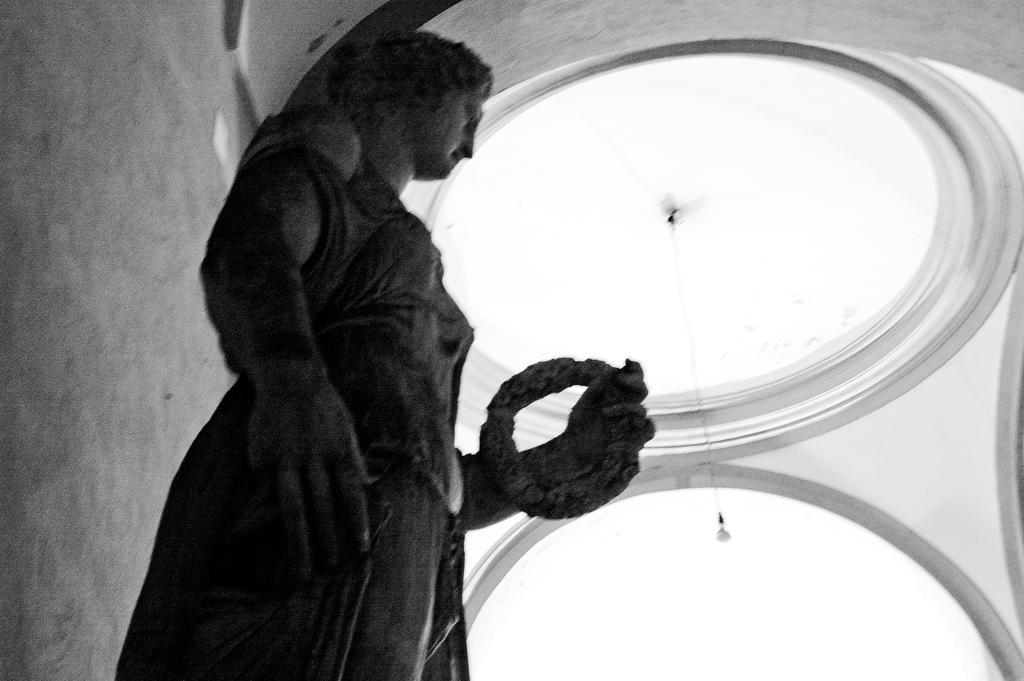In one or two sentences, can you explain what this image depicts? In this image in the front there is a statue. In the background there is a light hanging and there is a wall. 